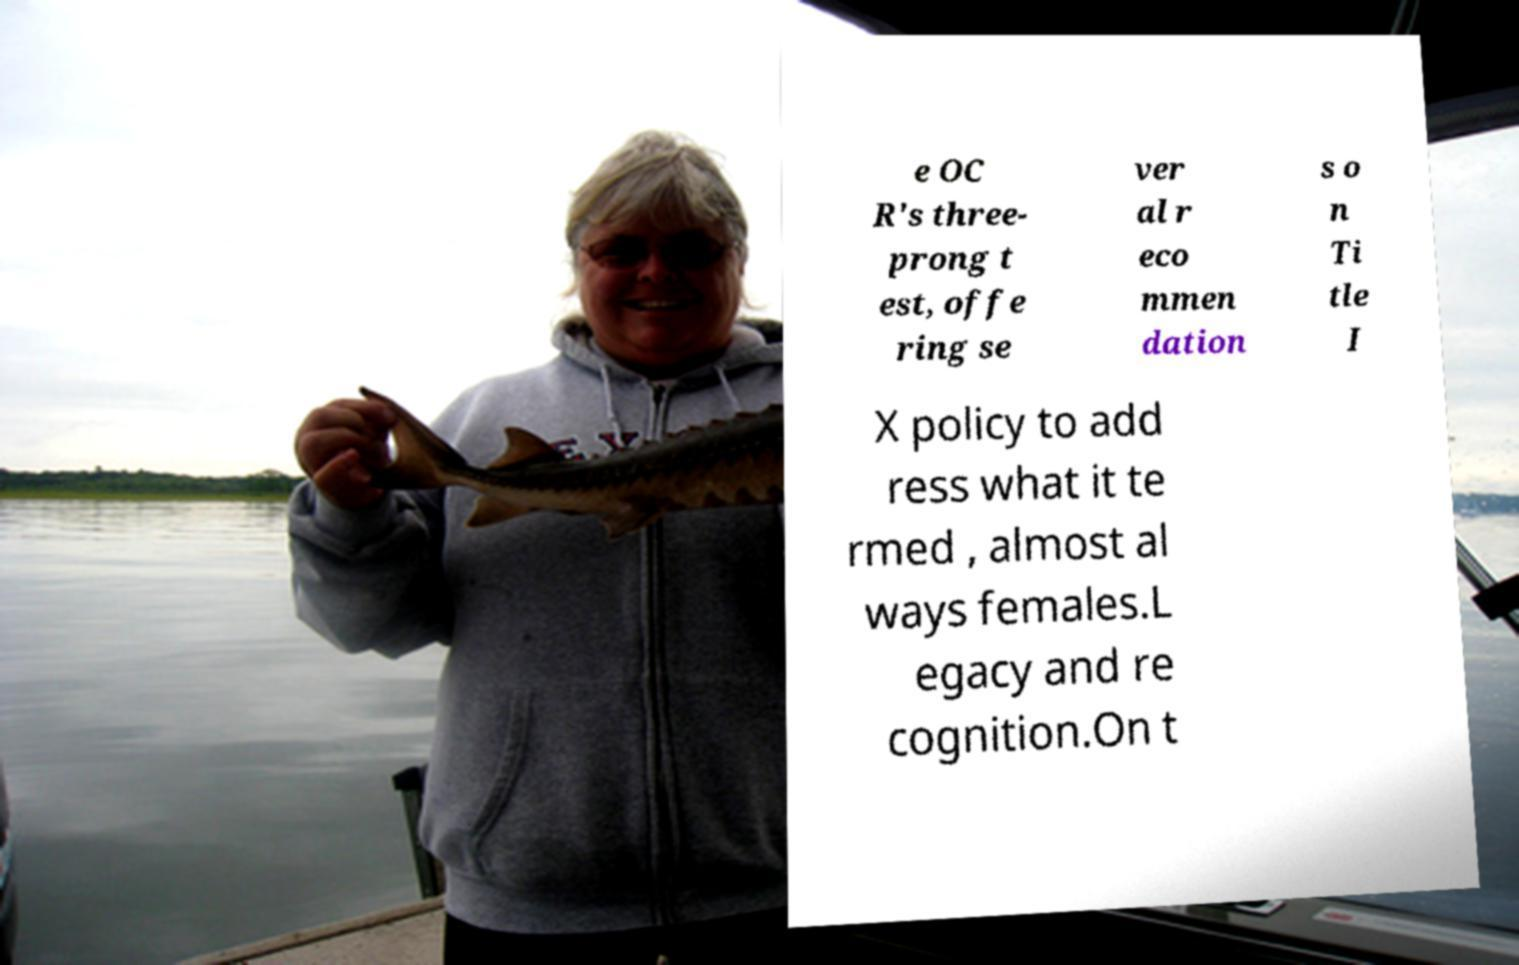Could you assist in decoding the text presented in this image and type it out clearly? e OC R's three- prong t est, offe ring se ver al r eco mmen dation s o n Ti tle I X policy to add ress what it te rmed , almost al ways females.L egacy and re cognition.On t 